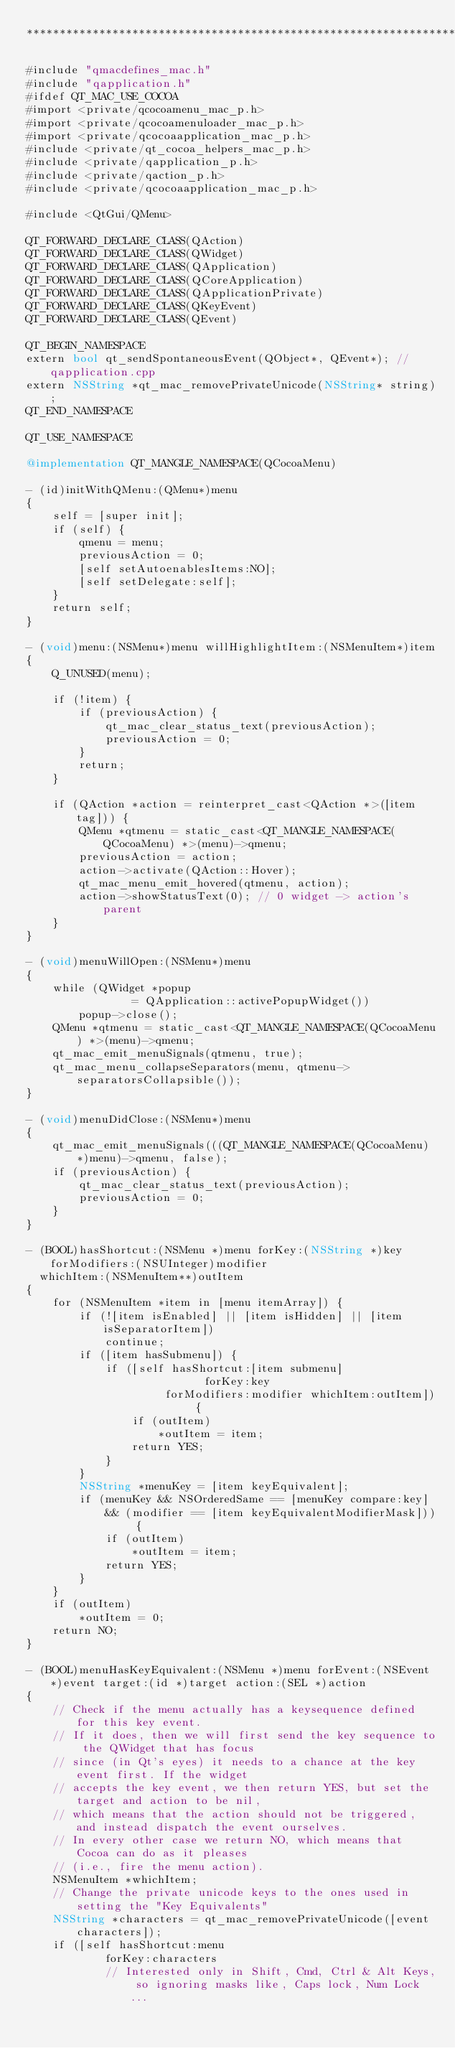Convert code to text. <code><loc_0><loc_0><loc_500><loc_500><_ObjectiveC_>****************************************************************************/

#include "qmacdefines_mac.h"
#include "qapplication.h"
#ifdef QT_MAC_USE_COCOA
#import <private/qcocoamenu_mac_p.h>
#import <private/qcocoamenuloader_mac_p.h>
#import <private/qcocoaapplication_mac_p.h>
#include <private/qt_cocoa_helpers_mac_p.h>
#include <private/qapplication_p.h>
#include <private/qaction_p.h>
#include <private/qcocoaapplication_mac_p.h>

#include <QtGui/QMenu>

QT_FORWARD_DECLARE_CLASS(QAction)
QT_FORWARD_DECLARE_CLASS(QWidget)
QT_FORWARD_DECLARE_CLASS(QApplication)
QT_FORWARD_DECLARE_CLASS(QCoreApplication)
QT_FORWARD_DECLARE_CLASS(QApplicationPrivate)
QT_FORWARD_DECLARE_CLASS(QKeyEvent)
QT_FORWARD_DECLARE_CLASS(QEvent)

QT_BEGIN_NAMESPACE
extern bool qt_sendSpontaneousEvent(QObject*, QEvent*); //qapplication.cpp
extern NSString *qt_mac_removePrivateUnicode(NSString* string);
QT_END_NAMESPACE

QT_USE_NAMESPACE

@implementation QT_MANGLE_NAMESPACE(QCocoaMenu)

- (id)initWithQMenu:(QMenu*)menu
{
    self = [super init];
    if (self) {
        qmenu = menu;
        previousAction = 0;
        [self setAutoenablesItems:NO];
        [self setDelegate:self];
    }
    return self;
}

- (void)menu:(NSMenu*)menu willHighlightItem:(NSMenuItem*)item
{
    Q_UNUSED(menu);

    if (!item) {
        if (previousAction) {
            qt_mac_clear_status_text(previousAction);
            previousAction = 0;
        }
        return;
    }

    if (QAction *action = reinterpret_cast<QAction *>([item tag])) {
        QMenu *qtmenu = static_cast<QT_MANGLE_NAMESPACE(QCocoaMenu) *>(menu)->qmenu;
        previousAction = action;
        action->activate(QAction::Hover);
        qt_mac_menu_emit_hovered(qtmenu, action);
        action->showStatusText(0); // 0 widget -> action's parent
    }
}

- (void)menuWillOpen:(NSMenu*)menu
{
    while (QWidget *popup
                = QApplication::activePopupWidget())
        popup->close();
    QMenu *qtmenu = static_cast<QT_MANGLE_NAMESPACE(QCocoaMenu) *>(menu)->qmenu;
    qt_mac_emit_menuSignals(qtmenu, true);
    qt_mac_menu_collapseSeparators(menu, qtmenu->separatorsCollapsible());
}

- (void)menuDidClose:(NSMenu*)menu
{
    qt_mac_emit_menuSignals(((QT_MANGLE_NAMESPACE(QCocoaMenu) *)menu)->qmenu, false);
    if (previousAction) {
        qt_mac_clear_status_text(previousAction);
        previousAction = 0;
    }
}

- (BOOL)hasShortcut:(NSMenu *)menu forKey:(NSString *)key forModifiers:(NSUInteger)modifier
  whichItem:(NSMenuItem**)outItem
{
    for (NSMenuItem *item in [menu itemArray]) {
        if (![item isEnabled] || [item isHidden] || [item isSeparatorItem])
            continue;
        if ([item hasSubmenu]) {
            if ([self hasShortcut:[item submenu]
                           forKey:key
                     forModifiers:modifier whichItem:outItem]) {
                if (outItem)
                    *outItem = item;
                return YES;
            }
        }
        NSString *menuKey = [item keyEquivalent];
        if (menuKey && NSOrderedSame == [menuKey compare:key]
            && (modifier == [item keyEquivalentModifierMask])) {
            if (outItem)
                *outItem = item;
            return YES;
        }
    }
    if (outItem)
        *outItem = 0;
    return NO;
}

- (BOOL)menuHasKeyEquivalent:(NSMenu *)menu forEvent:(NSEvent *)event target:(id *)target action:(SEL *)action
{
    // Check if the menu actually has a keysequence defined for this key event.
    // If it does, then we will first send the key sequence to the QWidget that has focus
    // since (in Qt's eyes) it needs to a chance at the key event first. If the widget
    // accepts the key event, we then return YES, but set the target and action to be nil,
    // which means that the action should not be triggered, and instead dispatch the event ourselves.
    // In every other case we return NO, which means that Cocoa can do as it pleases
    // (i.e., fire the menu action).
    NSMenuItem *whichItem;
    // Change the private unicode keys to the ones used in setting the "Key Equivalents"
    NSString *characters = qt_mac_removePrivateUnicode([event characters]);
    if ([self hasShortcut:menu
            forKey:characters
            // Interested only in Shift, Cmd, Ctrl & Alt Keys, so ignoring masks like, Caps lock, Num Lock ...</code> 